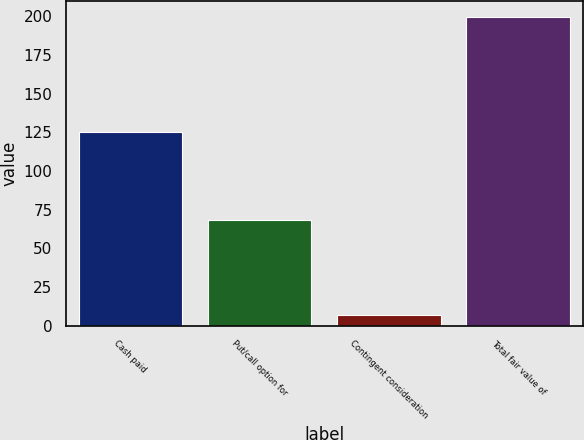<chart> <loc_0><loc_0><loc_500><loc_500><bar_chart><fcel>Cash paid<fcel>Put/call option for<fcel>Contingent consideration<fcel>Total fair value of<nl><fcel>125<fcel>68<fcel>6.8<fcel>199.8<nl></chart> 